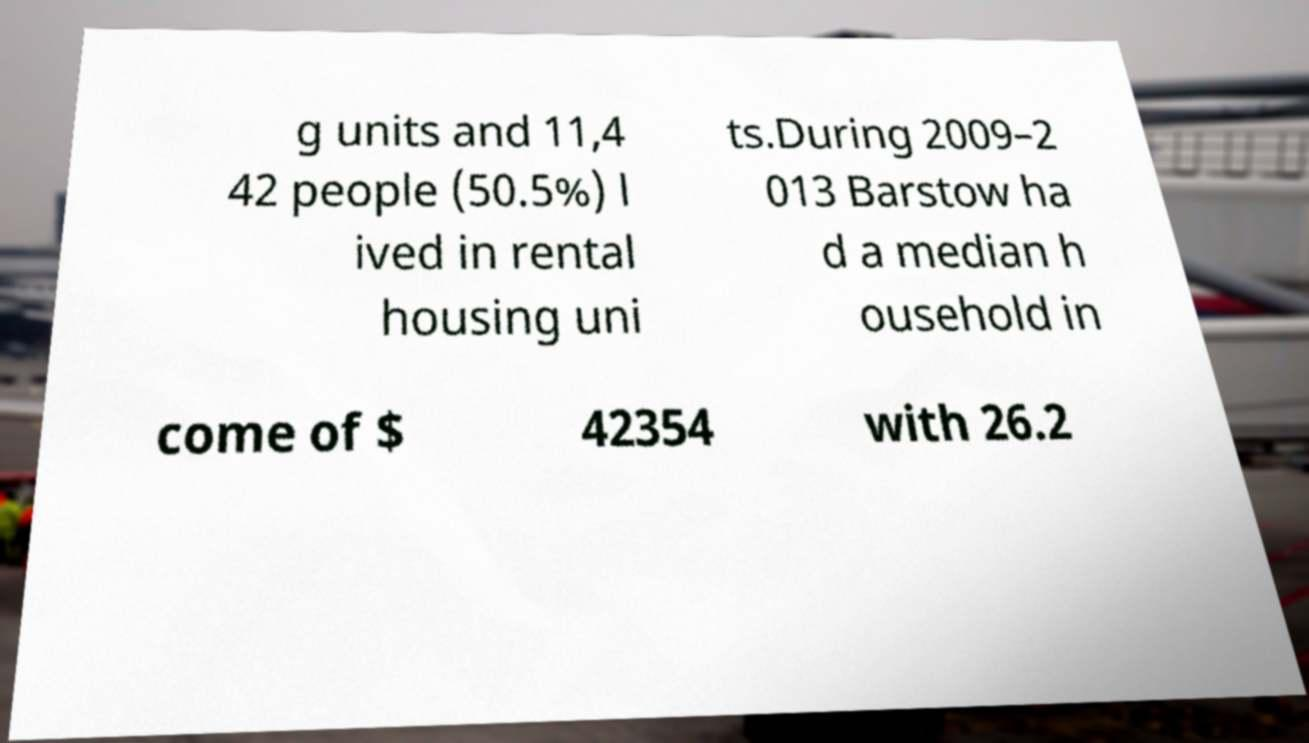Can you accurately transcribe the text from the provided image for me? g units and 11,4 42 people (50.5%) l ived in rental housing uni ts.During 2009–2 013 Barstow ha d a median h ousehold in come of $ 42354 with 26.2 